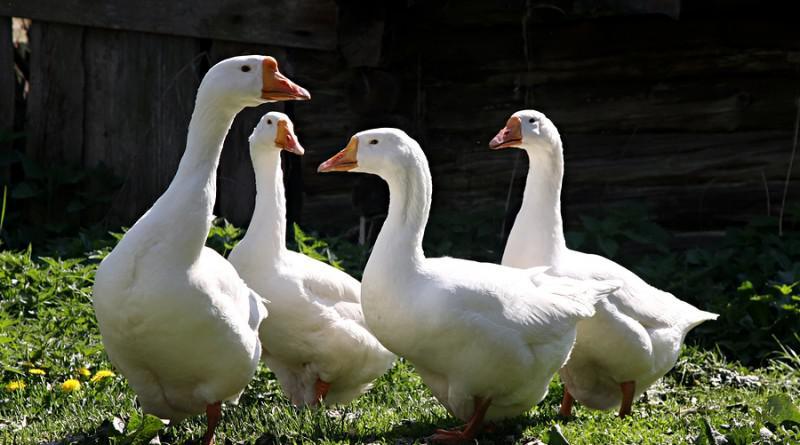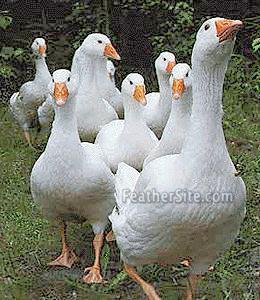The first image is the image on the left, the second image is the image on the right. Evaluate the accuracy of this statement regarding the images: "An image shows at least eight solid-white ducks moving toward the camera.". Is it true? Answer yes or no. Yes. The first image is the image on the left, the second image is the image on the right. Considering the images on both sides, is "A flock of all white geese are in at least one image." valid? Answer yes or no. Yes. 